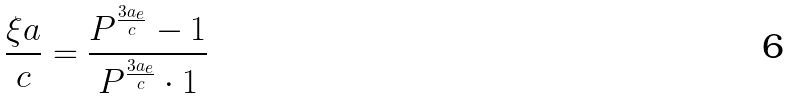Convert formula to latex. <formula><loc_0><loc_0><loc_500><loc_500>\frac { \xi a } { c } = \frac { P ^ { \frac { 3 a _ { e } } { c } } - 1 } { P ^ { \frac { 3 a _ { e } } { c } } \cdot 1 }</formula> 